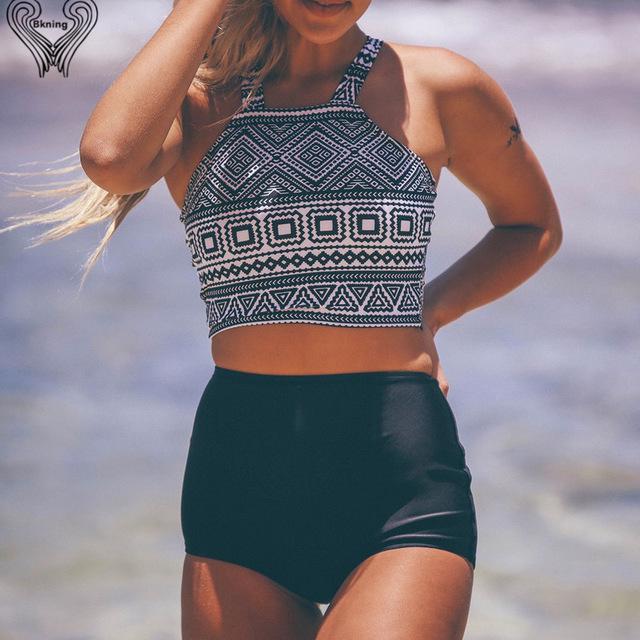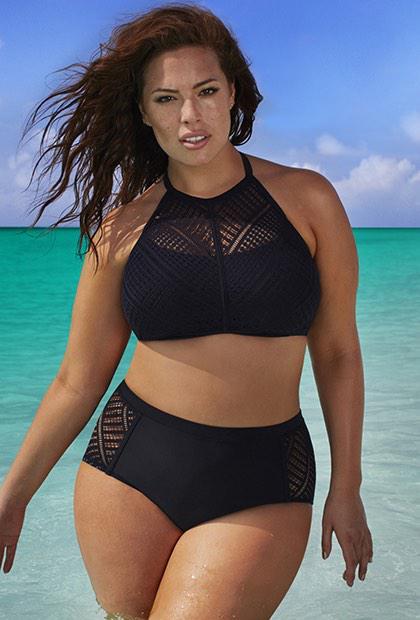The first image is the image on the left, the second image is the image on the right. Evaluate the accuracy of this statement regarding the images: "A woman is wearing a solid black two piece bathing suit.". Is it true? Answer yes or no. Yes. The first image is the image on the left, the second image is the image on the right. Given the left and right images, does the statement "the same model is wearing a bright green bikini" hold true? Answer yes or no. No. 